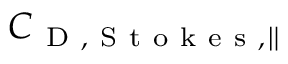<formula> <loc_0><loc_0><loc_500><loc_500>C _ { D , S t o k e s , \| }</formula> 